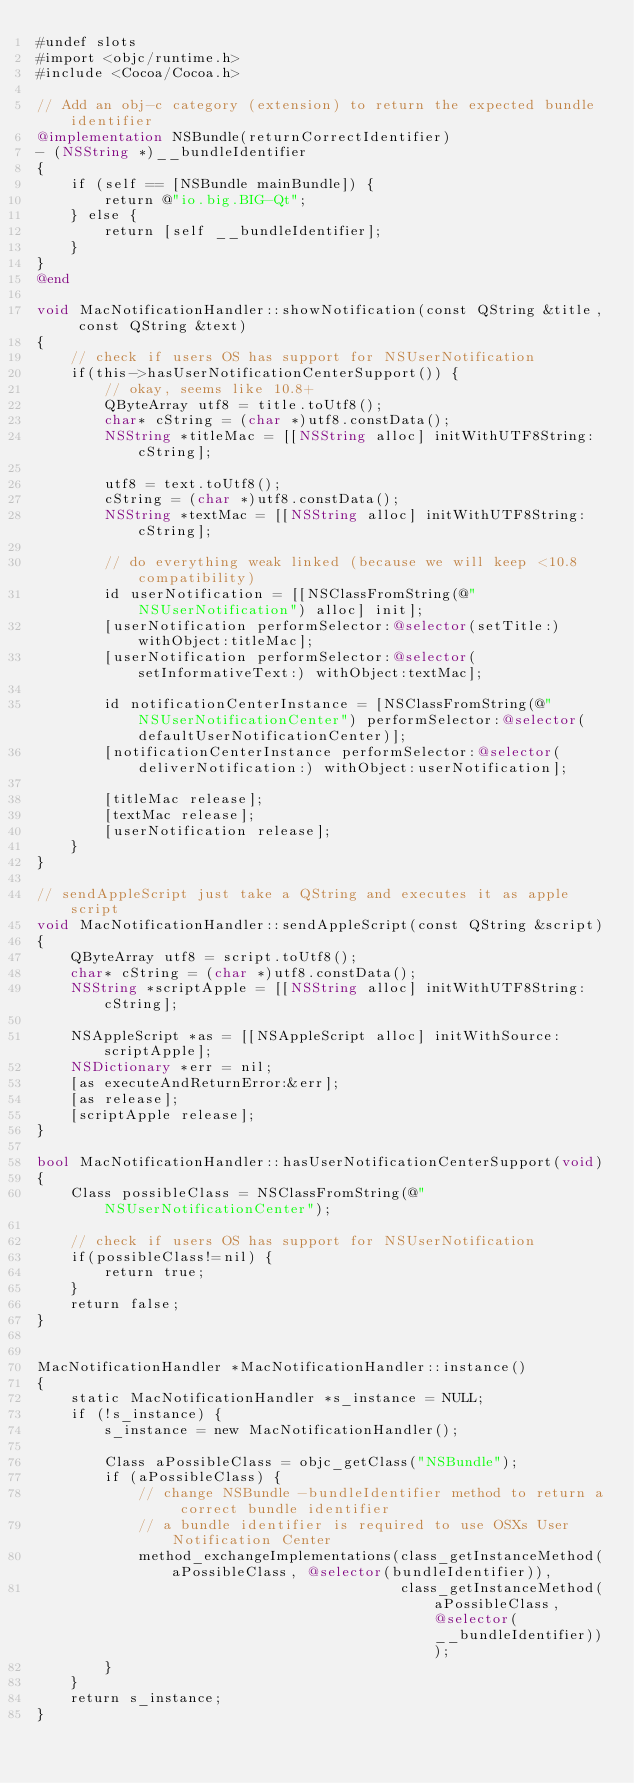<code> <loc_0><loc_0><loc_500><loc_500><_ObjectiveC_>#undef slots
#import <objc/runtime.h>
#include <Cocoa/Cocoa.h>

// Add an obj-c category (extension) to return the expected bundle identifier
@implementation NSBundle(returnCorrectIdentifier)
- (NSString *)__bundleIdentifier
{
    if (self == [NSBundle mainBundle]) {
        return @"io.big.BIG-Qt";
    } else {
        return [self __bundleIdentifier];
    }
}
@end

void MacNotificationHandler::showNotification(const QString &title, const QString &text)
{
    // check if users OS has support for NSUserNotification
    if(this->hasUserNotificationCenterSupport()) {
        // okay, seems like 10.8+
        QByteArray utf8 = title.toUtf8();
        char* cString = (char *)utf8.constData();
        NSString *titleMac = [[NSString alloc] initWithUTF8String:cString];

        utf8 = text.toUtf8();
        cString = (char *)utf8.constData();
        NSString *textMac = [[NSString alloc] initWithUTF8String:cString];

        // do everything weak linked (because we will keep <10.8 compatibility)
        id userNotification = [[NSClassFromString(@"NSUserNotification") alloc] init];
        [userNotification performSelector:@selector(setTitle:) withObject:titleMac];
        [userNotification performSelector:@selector(setInformativeText:) withObject:textMac];

        id notificationCenterInstance = [NSClassFromString(@"NSUserNotificationCenter") performSelector:@selector(defaultUserNotificationCenter)];
        [notificationCenterInstance performSelector:@selector(deliverNotification:) withObject:userNotification];

        [titleMac release];
        [textMac release];
        [userNotification release];
    }
}

// sendAppleScript just take a QString and executes it as apple script
void MacNotificationHandler::sendAppleScript(const QString &script)
{
    QByteArray utf8 = script.toUtf8();
    char* cString = (char *)utf8.constData();
    NSString *scriptApple = [[NSString alloc] initWithUTF8String:cString];

    NSAppleScript *as = [[NSAppleScript alloc] initWithSource:scriptApple];
    NSDictionary *err = nil;
    [as executeAndReturnError:&err];
    [as release];
    [scriptApple release];
}

bool MacNotificationHandler::hasUserNotificationCenterSupport(void)
{
    Class possibleClass = NSClassFromString(@"NSUserNotificationCenter");

    // check if users OS has support for NSUserNotification
    if(possibleClass!=nil) {
        return true;
    }
    return false;
}


MacNotificationHandler *MacNotificationHandler::instance()
{
    static MacNotificationHandler *s_instance = NULL;
    if (!s_instance) {
        s_instance = new MacNotificationHandler();
        
        Class aPossibleClass = objc_getClass("NSBundle");
        if (aPossibleClass) {
            // change NSBundle -bundleIdentifier method to return a correct bundle identifier
            // a bundle identifier is required to use OSXs User Notification Center
            method_exchangeImplementations(class_getInstanceMethod(aPossibleClass, @selector(bundleIdentifier)),
                                           class_getInstanceMethod(aPossibleClass, @selector(__bundleIdentifier)));
        }
    }
    return s_instance;
}
</code> 